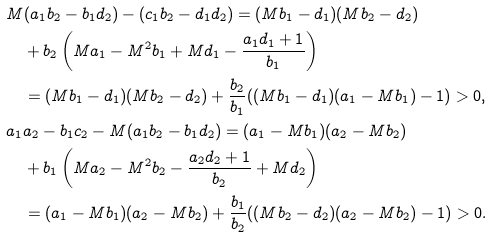Convert formula to latex. <formula><loc_0><loc_0><loc_500><loc_500>& M ( a _ { 1 } b _ { 2 } - b _ { 1 } d _ { 2 } ) - ( c _ { 1 } b _ { 2 } - d _ { 1 } d _ { 2 } ) = ( M b _ { 1 } - d _ { 1 } ) ( M b _ { 2 } - d _ { 2 } ) \\ & \quad + b _ { 2 } \left ( M a _ { 1 } - M ^ { 2 } b _ { 1 } + M d _ { 1 } - \frac { a _ { 1 } d _ { 1 } + 1 } { b _ { 1 } } \right ) \\ & \quad = ( M b _ { 1 } - d _ { 1 } ) ( M b _ { 2 } - d _ { 2 } ) + \frac { b _ { 2 } } { b _ { 1 } } ( ( M b _ { 1 } - d _ { 1 } ) ( a _ { 1 } - M b _ { 1 } ) - 1 ) > 0 , \\ & a _ { 1 } a _ { 2 } - b _ { 1 } c _ { 2 } - M ( a _ { 1 } b _ { 2 } - b _ { 1 } d _ { 2 } ) = ( a _ { 1 } - M b _ { 1 } ) ( a _ { 2 } - M b _ { 2 } ) \\ & \quad + b _ { 1 } \left ( M a _ { 2 } - M ^ { 2 } b _ { 2 } - \frac { a _ { 2 } d _ { 2 } + 1 } { b _ { 2 } } + M d _ { 2 } \right ) \\ & \quad = ( a _ { 1 } - M b _ { 1 } ) ( a _ { 2 } - M b _ { 2 } ) + \frac { b _ { 1 } } { b _ { 2 } } ( ( M b _ { 2 } - d _ { 2 } ) ( a _ { 2 } - M b _ { 2 } ) - 1 ) > 0 .</formula> 